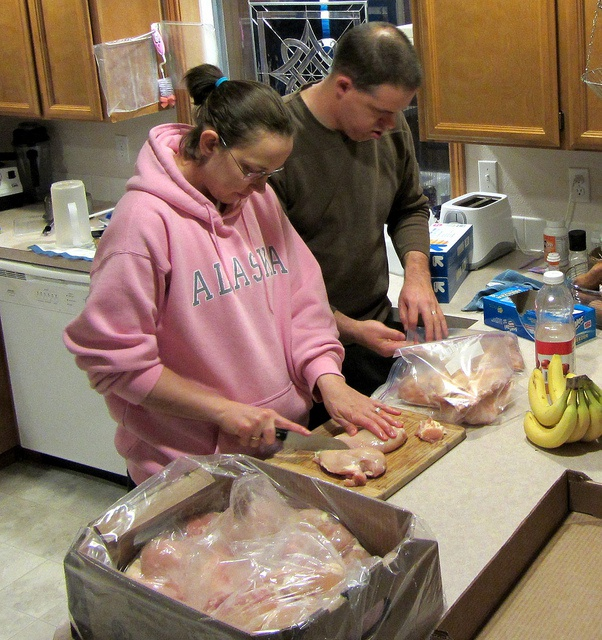Describe the objects in this image and their specific colors. I can see people in tan, lightpink, brown, maroon, and black tones, people in tan, black, maroon, and brown tones, banana in tan, khaki, and olive tones, toaster in tan, gray, darkgray, white, and black tones, and bottle in tan, darkgray, gray, and brown tones in this image. 